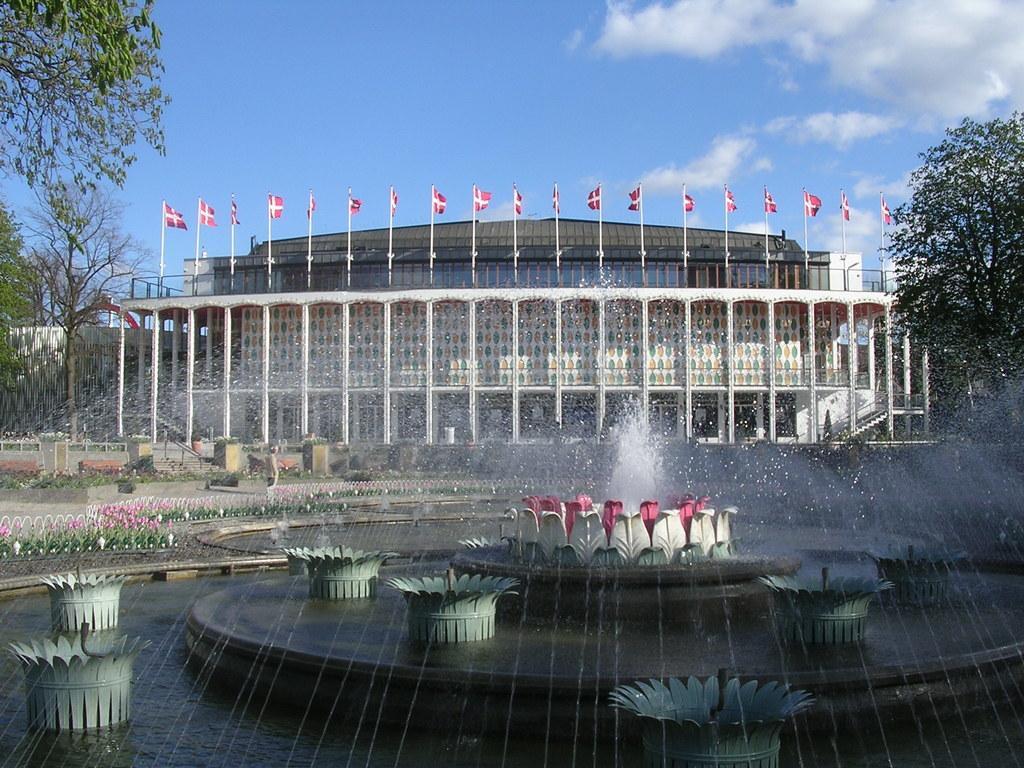Could you give a brief overview of what you see in this image? At the bottom of the image we can see a fountain. Behind the fountain there are some plants and buildings and trees, on the building there are some poles and flags. At the top of the image there are some clouds in the sky. 